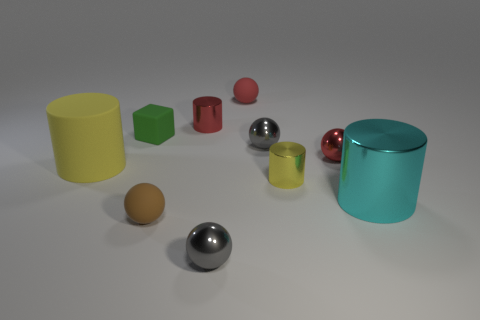Subtract 1 cylinders. How many cylinders are left? 3 Subtract 1 green cubes. How many objects are left? 9 Subtract all cubes. How many objects are left? 9 Subtract all purple spheres. Subtract all red cylinders. How many spheres are left? 5 Subtract all red blocks. How many purple cylinders are left? 0 Subtract all brown metal cylinders. Subtract all gray spheres. How many objects are left? 8 Add 1 gray balls. How many gray balls are left? 3 Add 6 shiny balls. How many shiny balls exist? 9 Subtract all cyan cylinders. How many cylinders are left? 3 Subtract all red shiny cylinders. How many cylinders are left? 3 